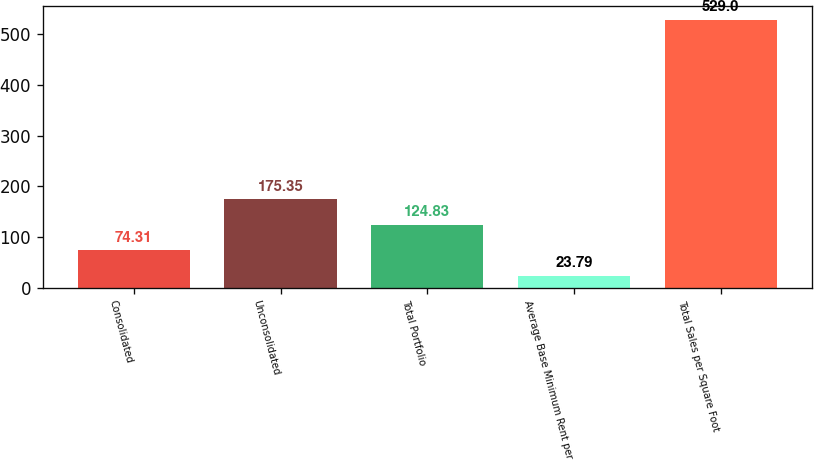Convert chart to OTSL. <chart><loc_0><loc_0><loc_500><loc_500><bar_chart><fcel>Consolidated<fcel>Unconsolidated<fcel>Total Portfolio<fcel>Average Base Minimum Rent per<fcel>Total Sales per Square Foot<nl><fcel>74.31<fcel>175.35<fcel>124.83<fcel>23.79<fcel>529<nl></chart> 